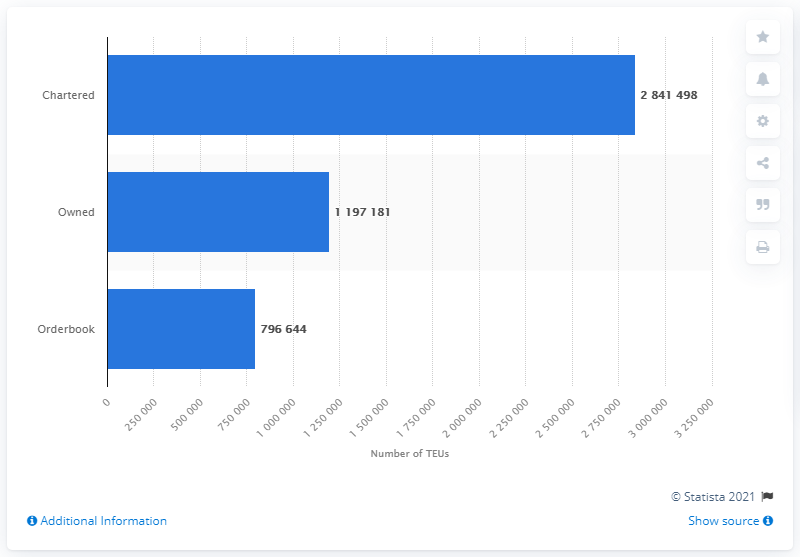Identify some key points in this picture. As of June 2021, the Mediterranean Shipping Company owned a total of 119,7181 containers, which was the capacity of its ships at that time. 